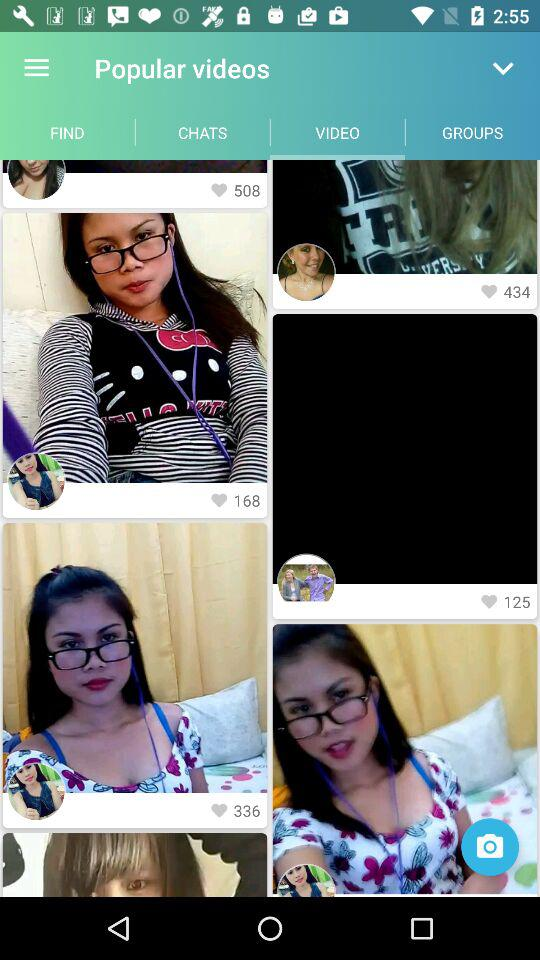Which tab is selected? The selected tab is "VIDEO". 